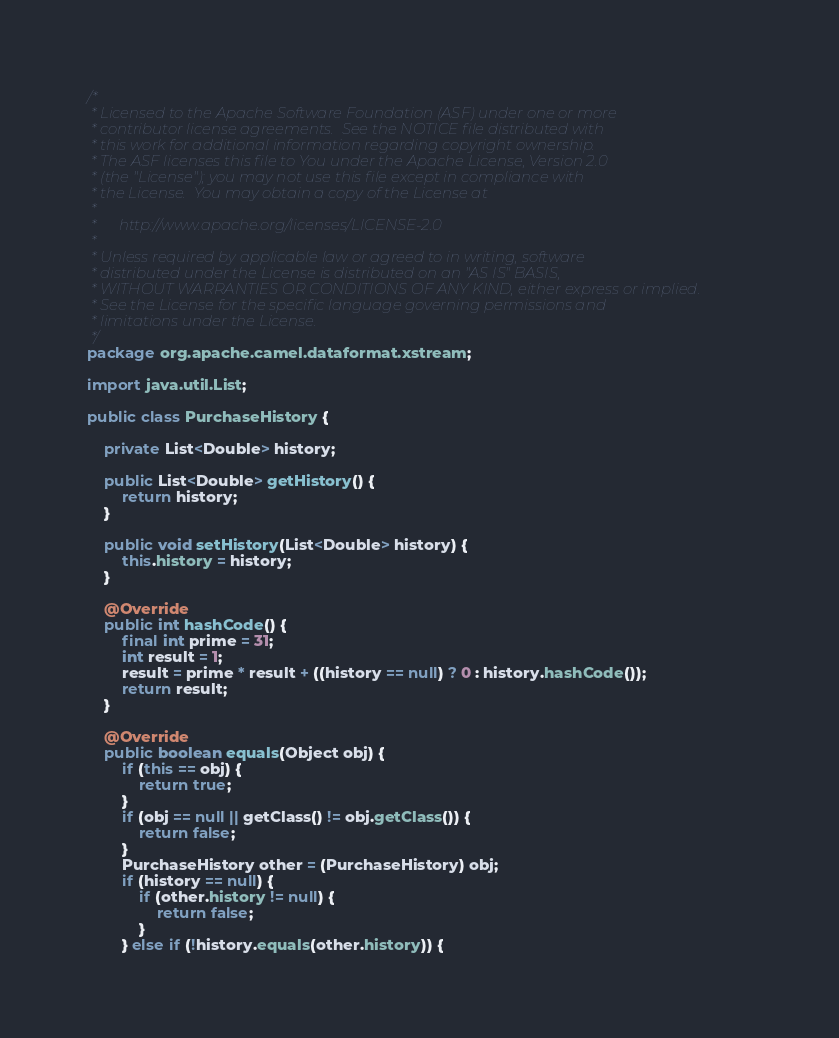Convert code to text. <code><loc_0><loc_0><loc_500><loc_500><_Java_>/*
 * Licensed to the Apache Software Foundation (ASF) under one or more
 * contributor license agreements.  See the NOTICE file distributed with
 * this work for additional information regarding copyright ownership.
 * The ASF licenses this file to You under the Apache License, Version 2.0
 * (the "License"); you may not use this file except in compliance with
 * the License.  You may obtain a copy of the License at
 *
 *      http://www.apache.org/licenses/LICENSE-2.0
 *
 * Unless required by applicable law or agreed to in writing, software
 * distributed under the License is distributed on an "AS IS" BASIS,
 * WITHOUT WARRANTIES OR CONDITIONS OF ANY KIND, either express or implied.
 * See the License for the specific language governing permissions and
 * limitations under the License.
 */
package org.apache.camel.dataformat.xstream;

import java.util.List;

public class PurchaseHistory {

    private List<Double> history;

    public List<Double> getHistory() {
        return history;
    }

    public void setHistory(List<Double> history) {
        this.history = history;
    }

    @Override
    public int hashCode() {
        final int prime = 31;
        int result = 1;
        result = prime * result + ((history == null) ? 0 : history.hashCode());
        return result;
    }

    @Override
    public boolean equals(Object obj) {
        if (this == obj) {
            return true;
        }
        if (obj == null || getClass() != obj.getClass()) {
            return false;
        }
        PurchaseHistory other = (PurchaseHistory) obj;
        if (history == null) {
            if (other.history != null) {
                return false;
            }
        } else if (!history.equals(other.history)) {</code> 